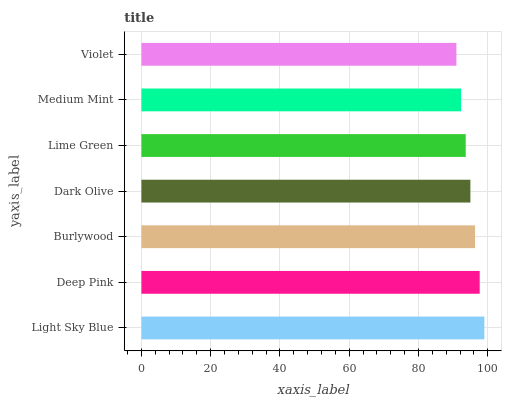Is Violet the minimum?
Answer yes or no. Yes. Is Light Sky Blue the maximum?
Answer yes or no. Yes. Is Deep Pink the minimum?
Answer yes or no. No. Is Deep Pink the maximum?
Answer yes or no. No. Is Light Sky Blue greater than Deep Pink?
Answer yes or no. Yes. Is Deep Pink less than Light Sky Blue?
Answer yes or no. Yes. Is Deep Pink greater than Light Sky Blue?
Answer yes or no. No. Is Light Sky Blue less than Deep Pink?
Answer yes or no. No. Is Dark Olive the high median?
Answer yes or no. Yes. Is Dark Olive the low median?
Answer yes or no. Yes. Is Medium Mint the high median?
Answer yes or no. No. Is Deep Pink the low median?
Answer yes or no. No. 